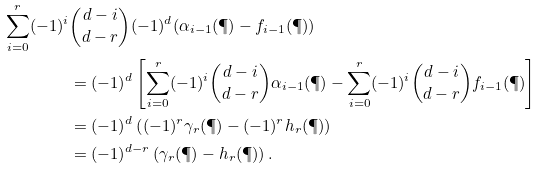Convert formula to latex. <formula><loc_0><loc_0><loc_500><loc_500>\sum _ { i = 0 } ^ { r } ( - 1 ) ^ { i } & { d - i \choose d - r } ( - 1 ) ^ { d } ( \alpha _ { i - 1 } ( \P ) - f _ { i - 1 } ( \P ) ) \\ & = ( - 1 ) ^ { d } \left [ \sum _ { i = 0 } ^ { r } ( - 1 ) ^ { i } { d - i \choose d - r } \alpha _ { i - 1 } ( \P ) - \sum _ { i = 0 } ^ { r } ( - 1 ) ^ { i } { d - i \choose d - r } f _ { i - 1 } ( \P ) \right ] \\ & = ( - 1 ) ^ { d } \left ( ( - 1 ) ^ { r } \gamma _ { r } ( \P ) - ( - 1 ) ^ { r } h _ { r } ( \P ) \right ) \\ & = ( - 1 ) ^ { d - r } \left ( \gamma _ { r } ( \P ) - h _ { r } ( \P ) \right ) .</formula> 